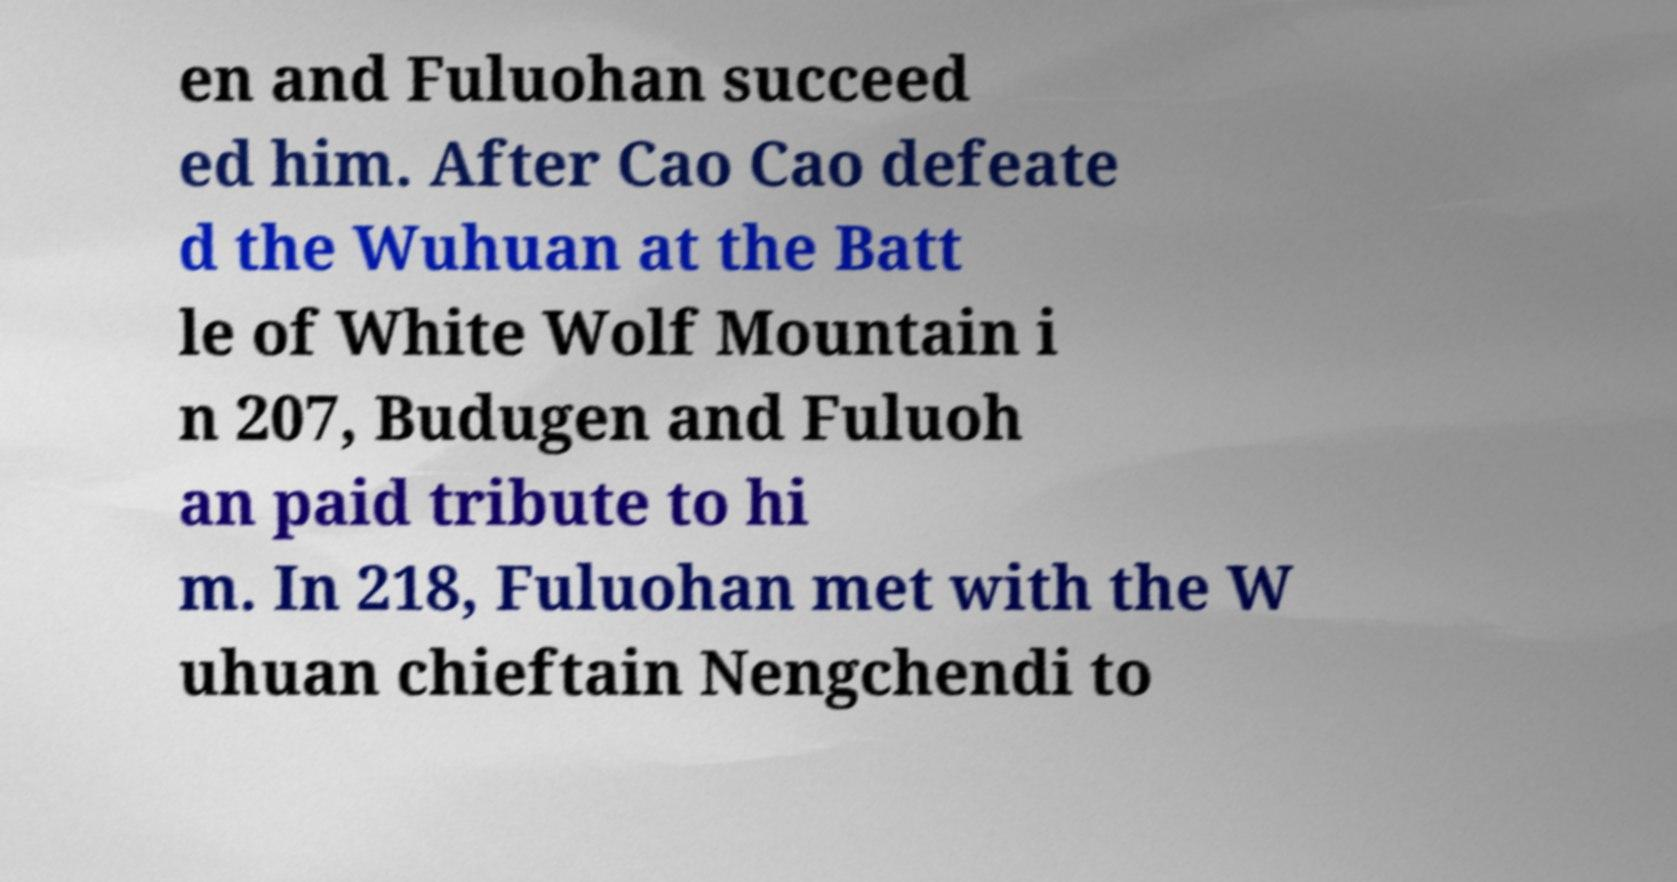For documentation purposes, I need the text within this image transcribed. Could you provide that? en and Fuluohan succeed ed him. After Cao Cao defeate d the Wuhuan at the Batt le of White Wolf Mountain i n 207, Budugen and Fuluoh an paid tribute to hi m. In 218, Fuluohan met with the W uhuan chieftain Nengchendi to 